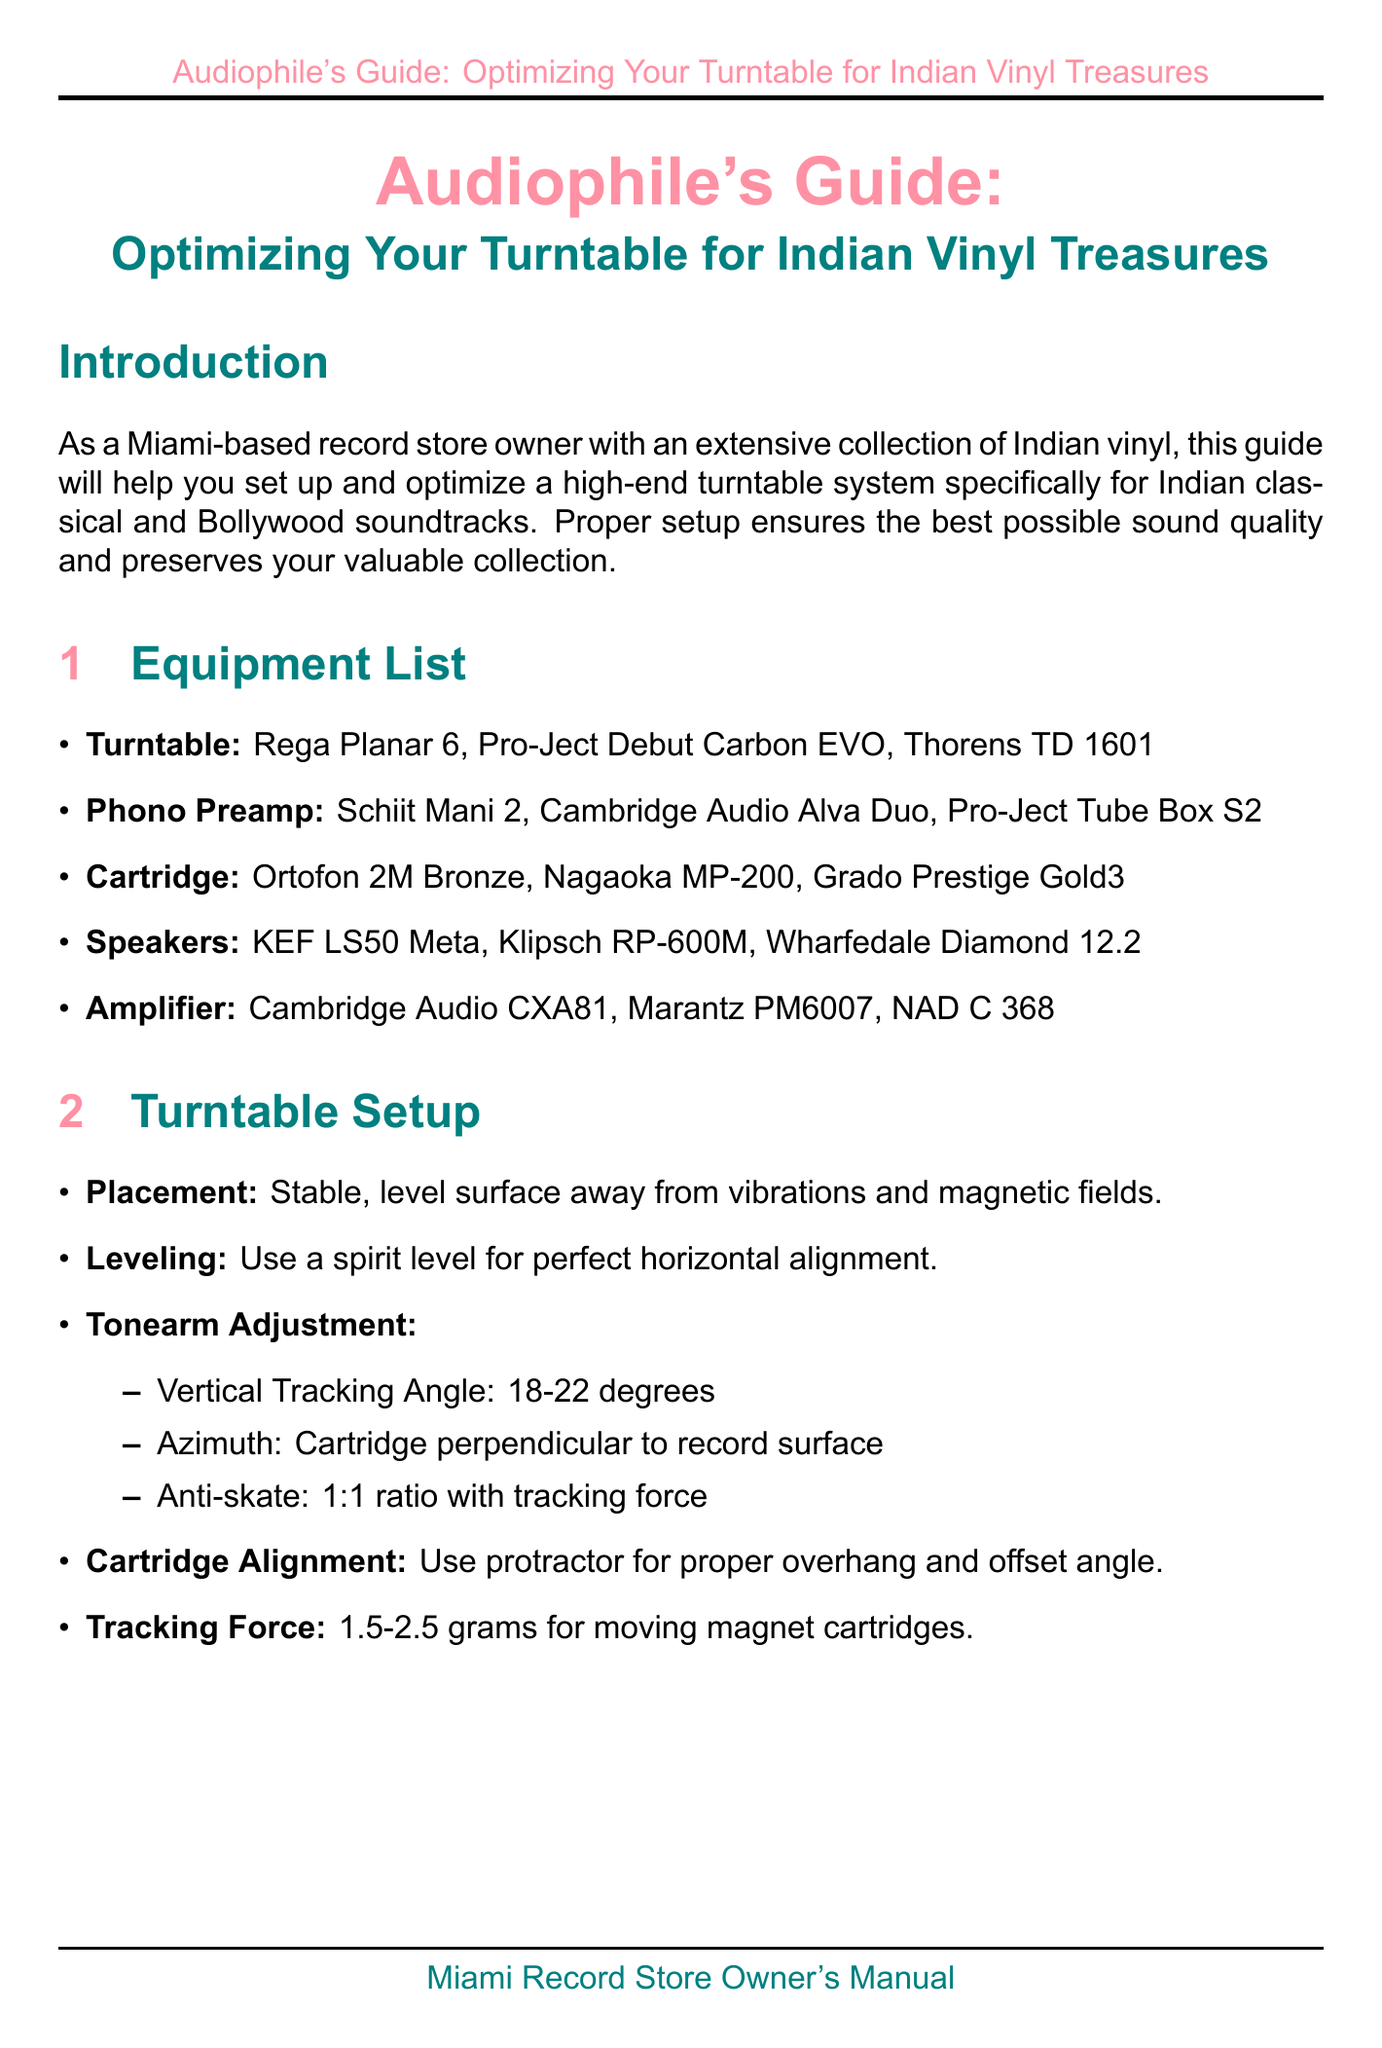What types of music does this guide focus on? The manual is specifically for Indian classical and Bollywood soundtracks.
Answer: Indian classical and Bollywood soundtracks What is the recommended turntable model? The manual lists several models, and one of them is the Rega Planar 6.
Answer: Rega Planar 6 What is the ideal vertical tracking angle? The document specifies that the vertical tracking angle should be between 18-22 degrees.
Answer: 18-22 degrees What maintenance task should be done annually? The document suggests replacing the belt annually or when signs of stretching appear.
Answer: Belt replacement What is essential for speaker placement? The manual states that speakers should form an equilateral triangle with the listening position.
Answer: Equilateral triangle Which cartridge is recommended for its frequency response? The Nagaoka MP-200 is one of the recommended cartridges for its performance.
Answer: Nagaoka MP-200 What humidity level should be maintained for record preservation? The document mentions that the humidity should be maintained at 45-50 percent.
Answer: 45-50 percent What is a common issue with inner groove distortion? The manual indicates checking cartridge alignment to address inner groove distortion.
Answer: Cartridge alignment 